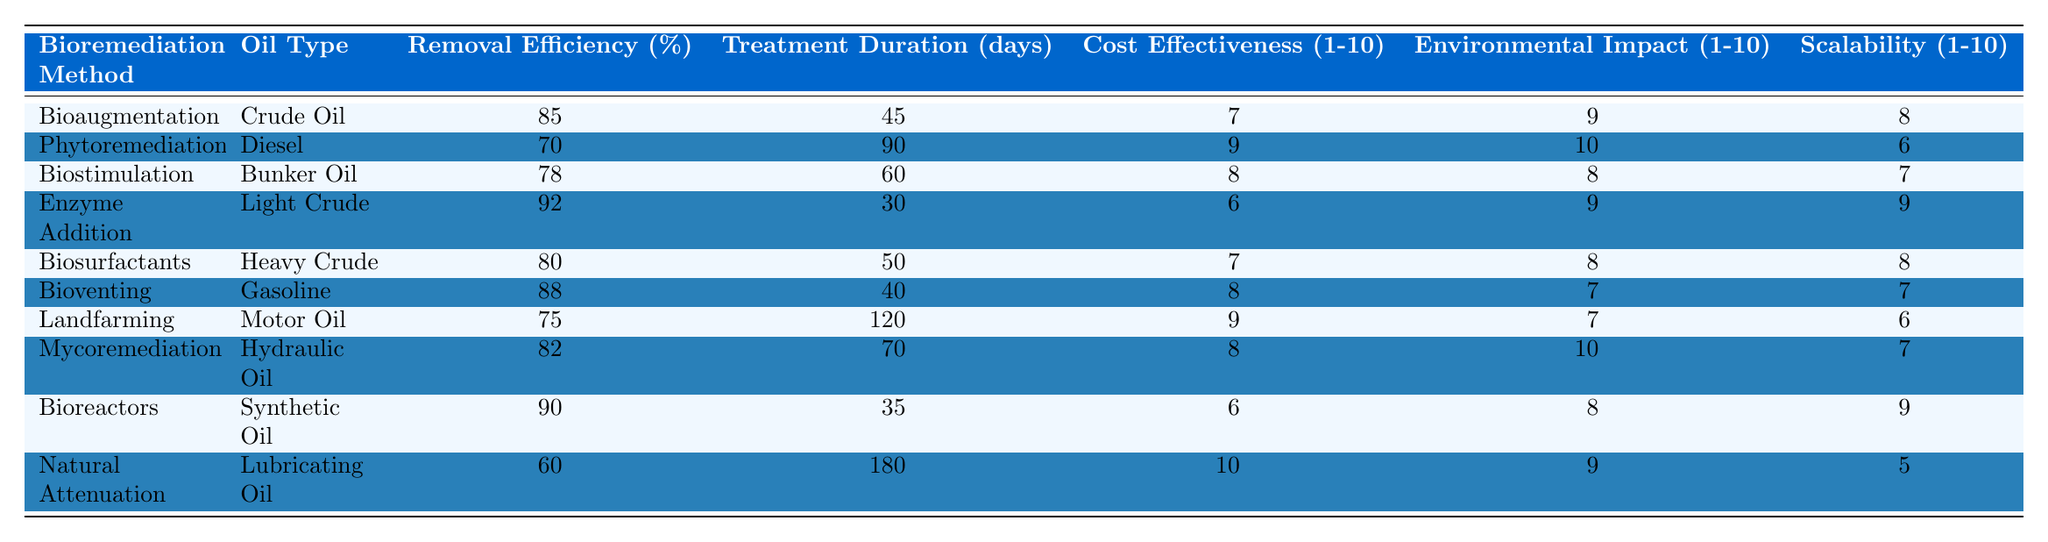What is the removal efficiency of the enzyme addition method? The table lists the removal efficiency of enzyme addition as 92%.
Answer: 92% Which bioremediation method has the highest removal efficiency? By examining the removal efficiency column, enzyme addition has the highest value at 92%.
Answer: Enzyme Addition What is the cost-effectiveness rating of bioaugmentation? The cost-effectiveness rating for bioaugmentation is 7, as indicated in the table.
Answer: 7 How many days were required for landfarming treatment? The treatment duration for landfarming is provided as 120 days in the table.
Answer: 120 days Is the removal efficiency of mycoremediation greater than 80%? Since mycoremediation has a removal efficiency of 82%, which is greater than 80%, the answer is yes.
Answer: Yes Which oil type had the longest treatment duration, and what was it? The longest treatment duration is 180 days, associated with natural attenuation, according to the table.
Answer: Lubricating Oil, 180 days What is the average cost-effectiveness rating of the bioremediation methods listed? The sum of the cost-effectiveness ratings is 54 (7 + 9 + 8 + 6 + 7 + 8 + 9 + 8 + 6 + 10) with 10 methods total, hence the average is 54/10 = 5.4.
Answer: 5.4 Which method has the highest environmental impact rating? Phytoremediation has the highest environmental impact rating of 10, as confirmed from the table.
Answer: Phytoremediation What is the sum of treatment duration for bioaugmentation, enzyme addition, and bioreactors? The treatment durations are 45 days (bioaugmentation), 30 days (enzyme addition), and 35 days (bioreactors); their sum is 45 + 30 + 35 = 110 days.
Answer: 110 days How does the removal efficiency of natural attenuation compare to bioventing? Natural attenuation has a removal efficiency of 60%, while bioventing has 88%; so, natural attenuation is less effective than bioventing.
Answer: Less effective Which method, among those listed, offers the best scalability rating? The enzyme addition method has a scalability rating of 9, which is the highest among the listed methods.
Answer: Enzyme Addition Is there a method that achieves over 90% removal efficiency with a treatment duration under 40 days? Yes, enzyme addition achieves a 92% removal efficiency within 30 days, meeting both criteria.
Answer: Yes 